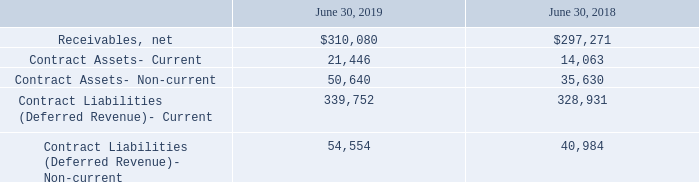Contract Balances
The following table provides information about contract assets and contract liabilities from contracts with customers.
Contract assets primarily result from revenue being recognized when or as control of a solution or service is transferred to the customer, but where invoicing is delayed until the completion of other performance obligations or payment terms differ from the provisioning of services. The current portion of contract assets is reported within prepaid expenses and other in the consolidated balance sheet, and the non-current portion is included in other non-current assets. Contract liabilities (deferred revenue) primarily relate to consideration received from customers in advance of delivery of the related goods and services to the customer. Contract balances are reported in a net contract asset or liability position on a contract-by-contract basis at the end of each reporting period.
The Company analyzes contract language to identify if a significant financing component does exist, and would adjust the transaction price for any material effects of the time value of money if the timing of payments provides either party to the contract with a significant benefit of financing the transaction.
During the fiscal years ended June 30, 2019, 2018, and 2017, the Company recognized revenue of $265,946, $269,593, and $264,517, respectively, that was included in the corresponding deferred revenue balance at the beginning of the periods.
Revenue recognized that related to performance obligations satisfied (or partially satisfied) in prior periods were immaterial for each period presented. These adjustments are primarily the result of transaction price adjustments and re-allocations due to changes in estimates of variable consideration.
What information does the table show? Information about contract assets and contract liabilities from contracts with customers. What is the net receivables as at June 30, 2019? $310,080. What is the current contract assets as at June 30, 2019? 21,446. Between June 30, 2019 and June 30, 2018, which year end had higher net receivables? $310,080>$297,271
Answer: 2019. Is current or non-current contract assets as at June 30, 2019 higher? 50,640>21,446
Answer: contract assets- non-current. What is the average net receivables for 2018 and 2019? (310,080+297,271)/2
Answer: 303675.5. 